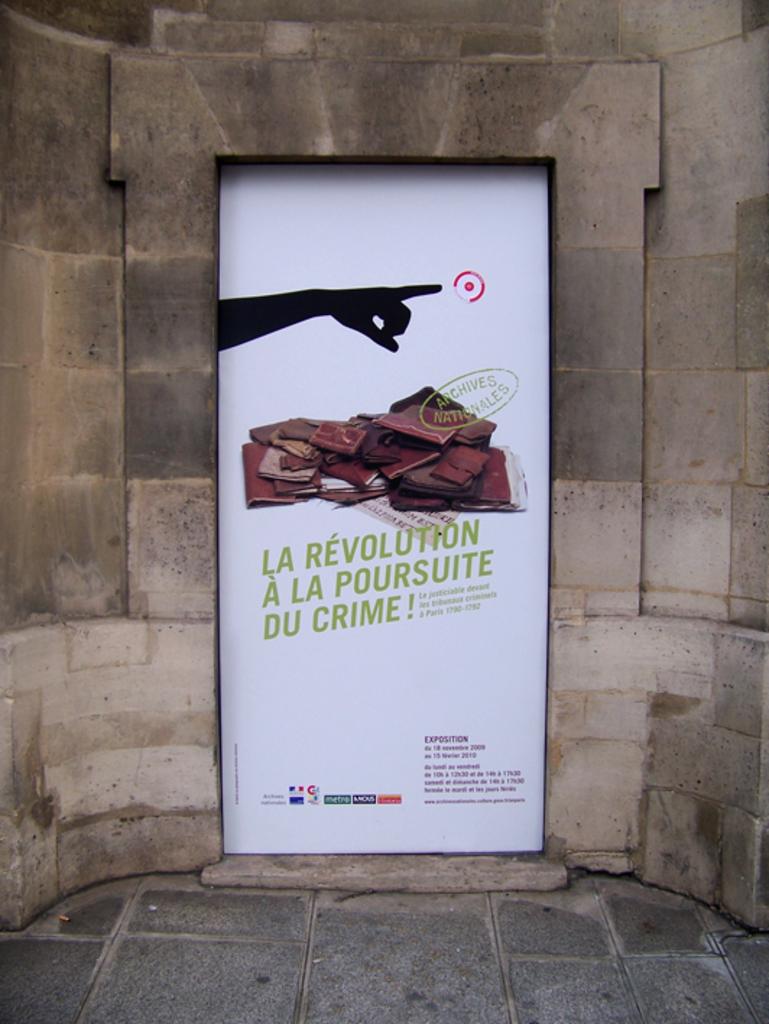Is the poster in english?
Provide a succinct answer. No. What does the gold text say?
Give a very brief answer. Archives nationales. 